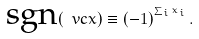<formula> <loc_0><loc_0><loc_500><loc_500>\text {sgn} ( \ v c { x } ) \equiv ( - 1 ) ^ { ^ { \sum _ { i } x _ { i } } } \, .</formula> 